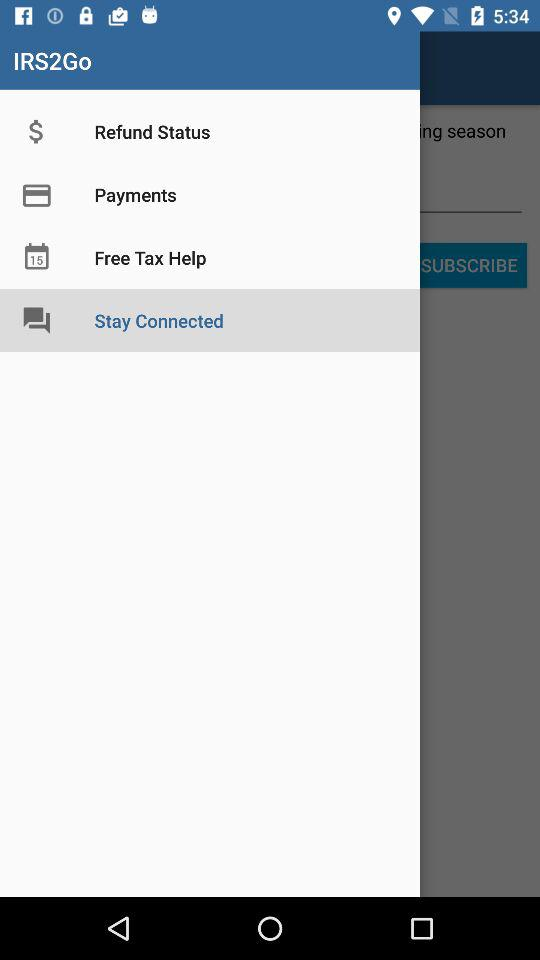How many notifications are there in "Payments"?
When the provided information is insufficient, respond with <no answer>. <no answer> 